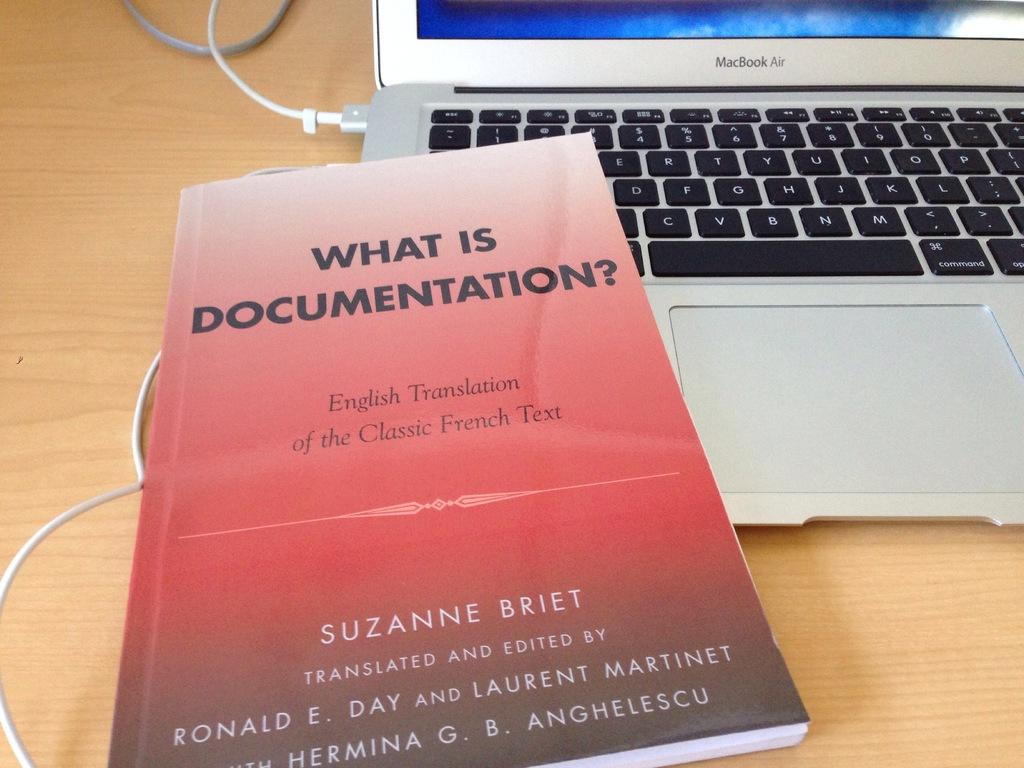<image>
Describe the image concisely. a book on top of a macbook air that is titled 'what is documentation?' 